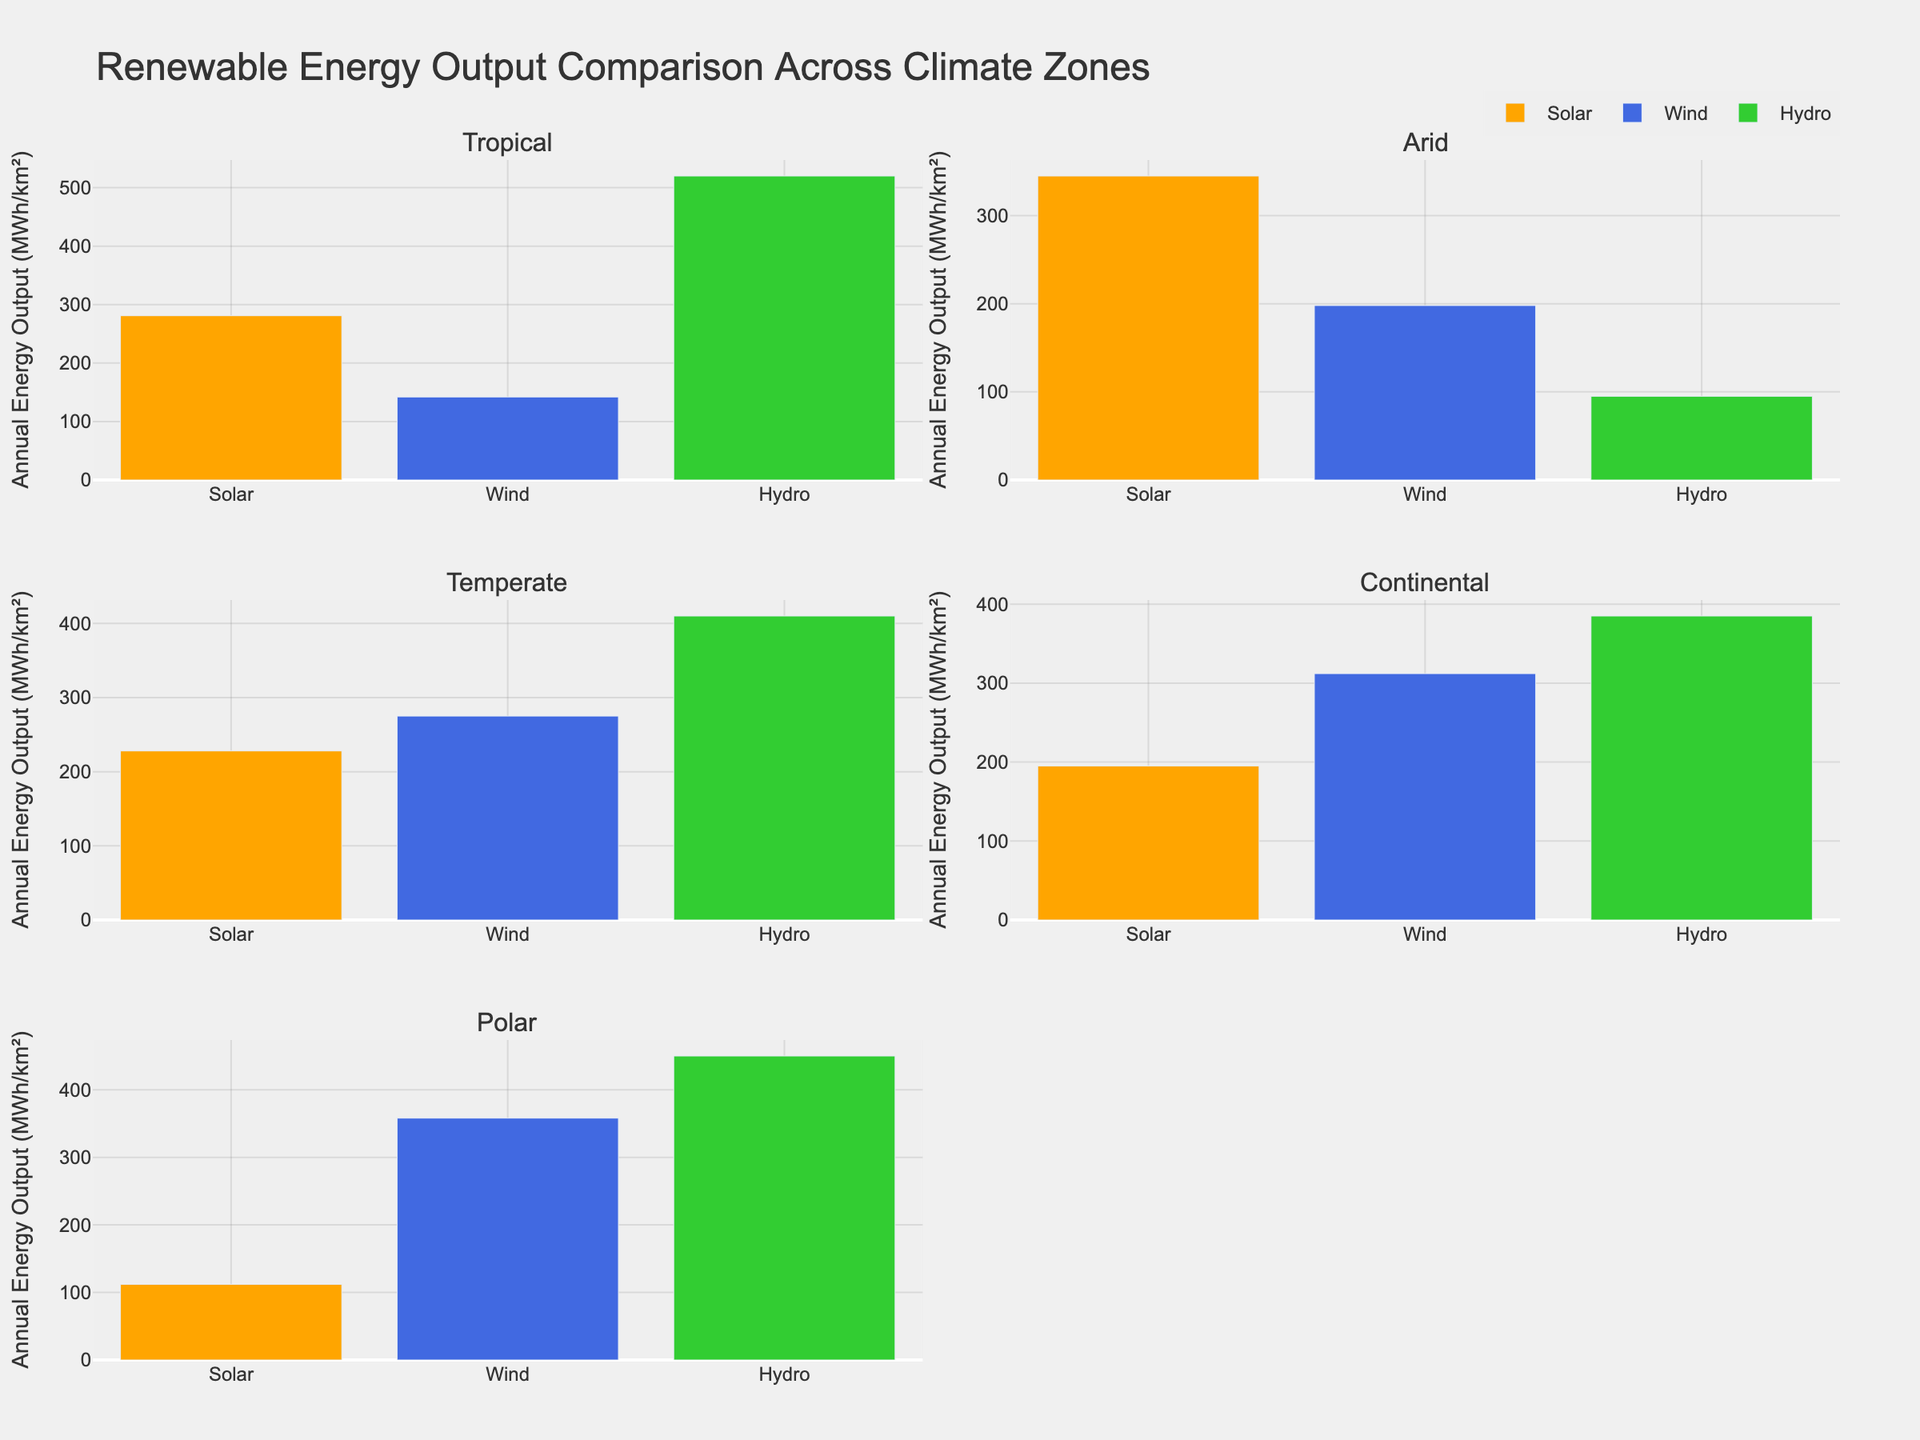How many subplots are present in the figure? The layout specifies 3 rows and 2 columns for the subplots. Multiplying the number of rows by the number of columns (3 * 2) gives 6 subplots.
Answer: 6 What is the color used to represent Solar energy in the plot? The colors assigned to each energy source are given in the code, with Solar energy represented by the color orange.
Answer: orange In which climate zone is the annual energy output from Wind higher than Solar? By examining each subplot, we find that in 'Temperate', 'Continental', and 'Polar' climate zones, the bars for Wind are taller than for Solar.
Answer: Temperate, Continental, Polar What is the total annual energy output for Arid climate zone considering all energy sources? Summing the annual energy output for Solar (345 MWh/km²), Wind (198 MWh/km²), and Hydro (95 MWh/km²) in the Arid climate zone results in 345 + 198 + 95 = 638 MWh/km².
Answer: 638 MWh/km² Which renewable source has the highest overall energy output in Continental climate zones? In the Continental subplot, compare the heights of the bars for Solar (195 MWh/km²), Wind (312 MWh/km²), and Hydro (385 MWh/km²). Hydro has the highest value.
Answer: Hydro By how much does the energy output of Hydro in the Tropical zone exceed that of Wind in the same zone? The energy output for Hydro in the Tropical zone is 520 MWh/km² and for Wind, it is 142 MWh/km². The difference is 520 - 142 = 378 MWh/km².
Answer: 378 MWh/km² Which climate zone has the lowest annual energy output for Solar energy? Comparing all the subplots for Solar energy, the shortest bar is in the Polar climate zone with a value of 112 MWh/km².
Answer: Polar In the respective subplots, how does the energy output of Wind in the Polar zone compare to the energy output of Solar in the Tropical zone? Wind in the Polar zone has an energy output of 358 MWh/km², while Solar in the Tropical zone has 281 MWh/km². Thus, Wind in the Polar zone exceeds Solar in the Tropical zone by 358 - 281 = 77 MWh/km².
Answer: 77 MWh/km² 